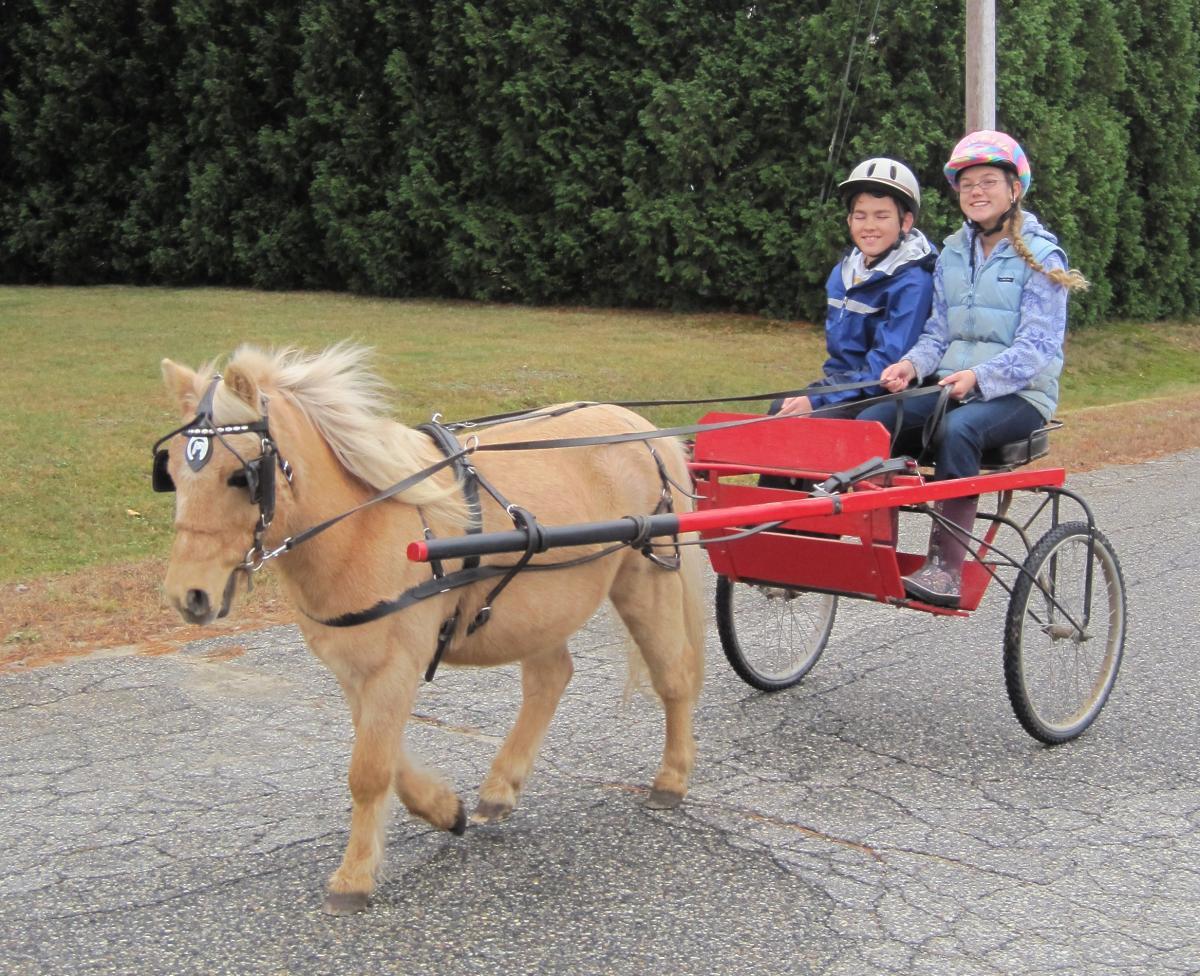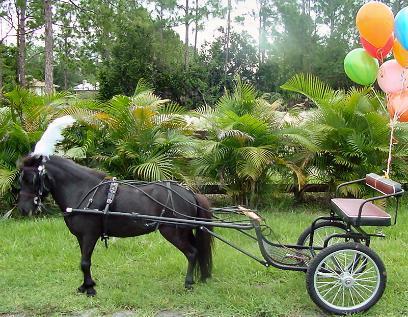The first image is the image on the left, the second image is the image on the right. Assess this claim about the two images: "There is one human being pulled by a horse facing right.". Correct or not? Answer yes or no. No. The first image is the image on the left, the second image is the image on the right. Analyze the images presented: Is the assertion "There are two humans riding a horse carriage in one of the images." valid? Answer yes or no. Yes. 